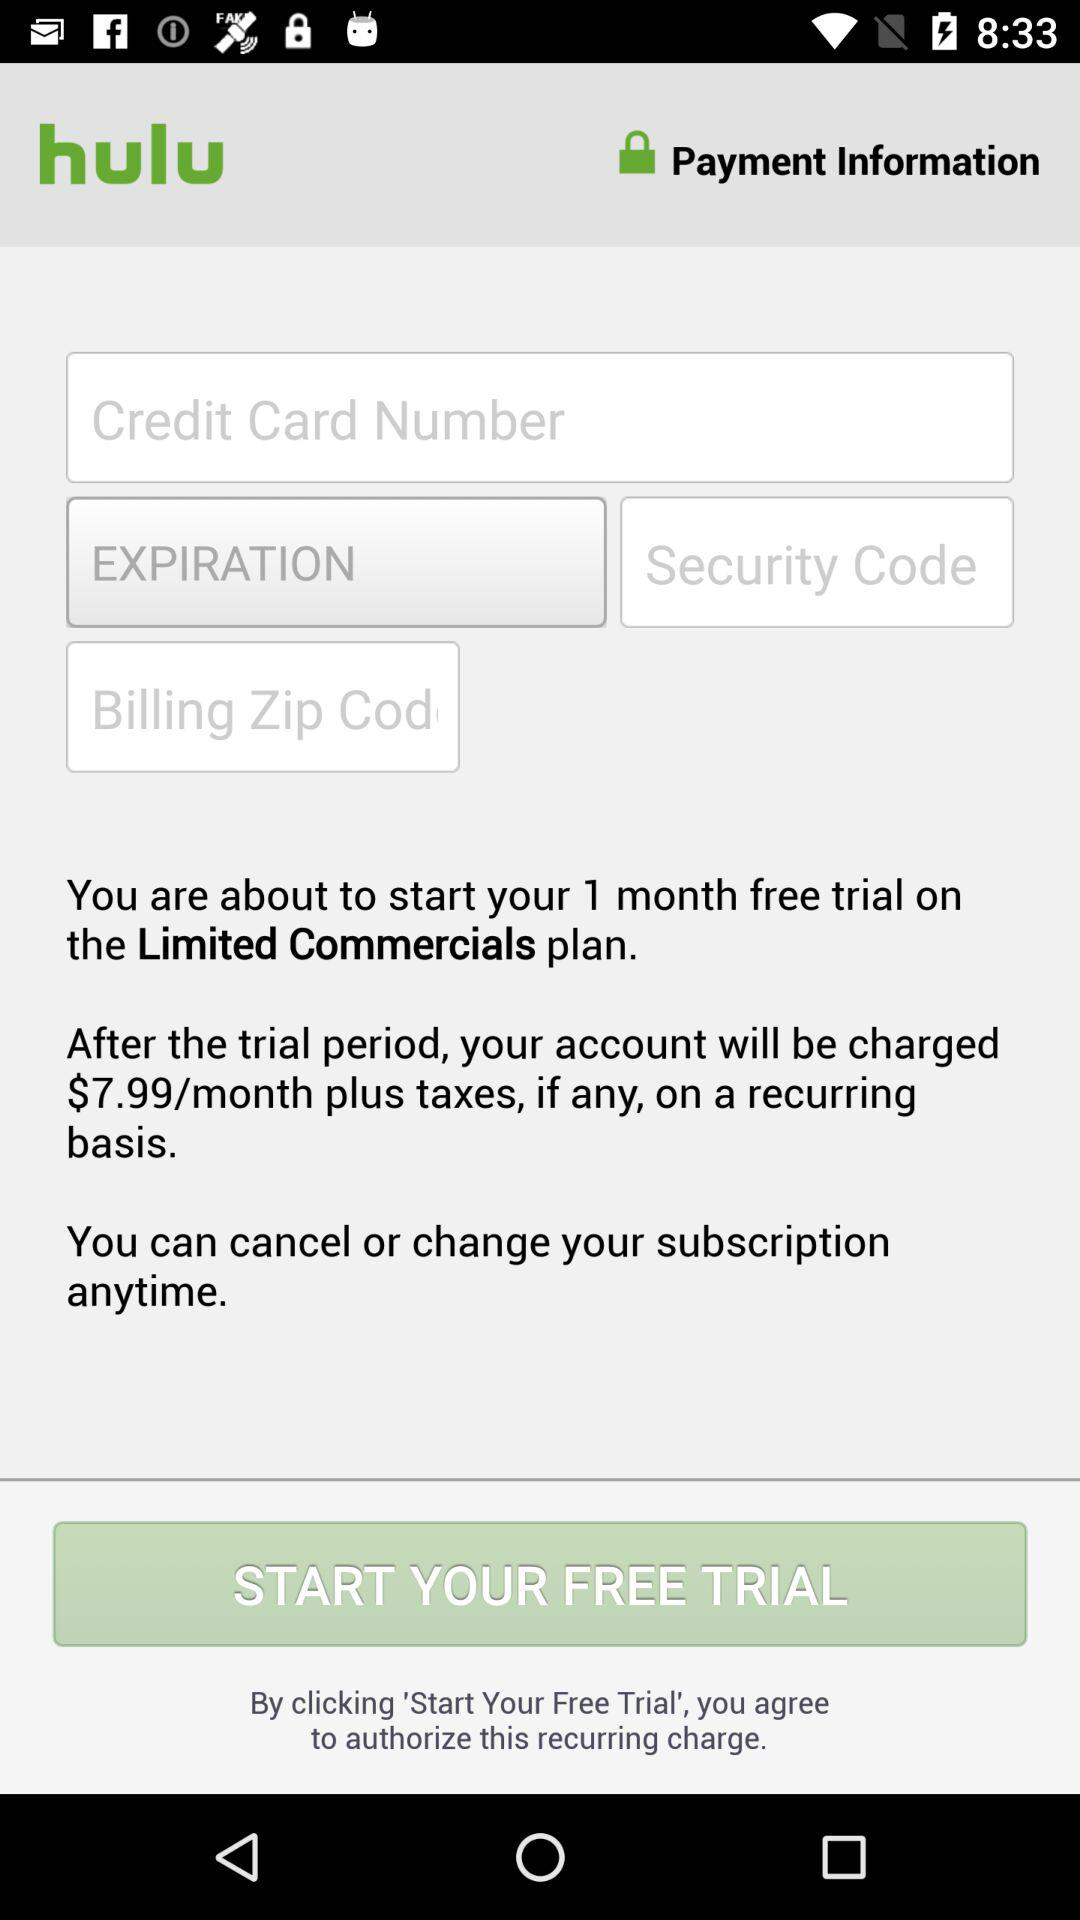How many months is the free trial for? The free trial is for 1 month. 